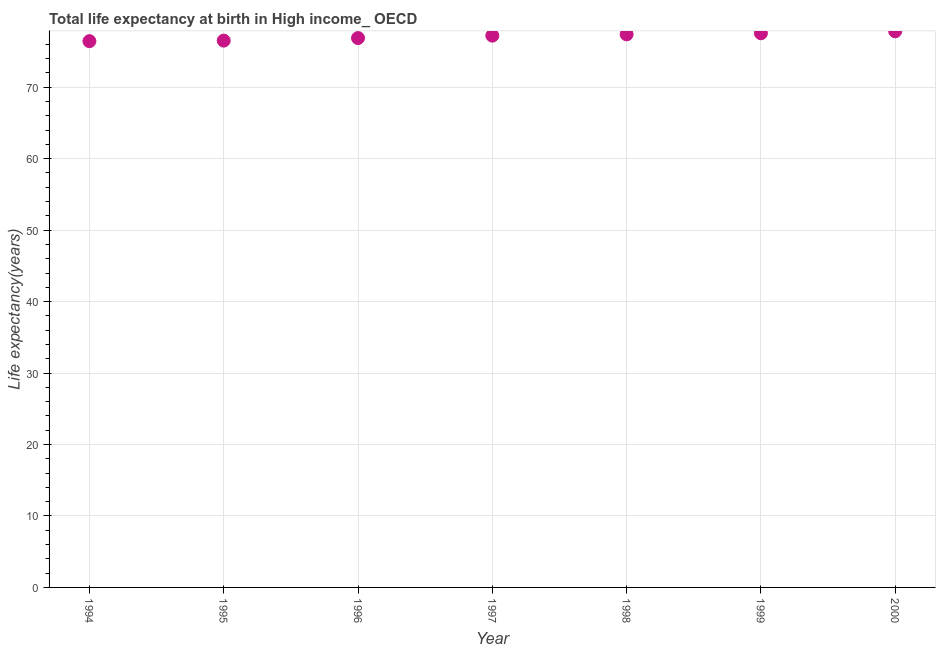What is the life expectancy at birth in 1997?
Provide a short and direct response. 77.22. Across all years, what is the maximum life expectancy at birth?
Make the answer very short. 77.83. Across all years, what is the minimum life expectancy at birth?
Keep it short and to the point. 76.45. In which year was the life expectancy at birth minimum?
Keep it short and to the point. 1994. What is the sum of the life expectancy at birth?
Offer a very short reply. 539.85. What is the difference between the life expectancy at birth in 1996 and 1999?
Provide a short and direct response. -0.67. What is the average life expectancy at birth per year?
Give a very brief answer. 77.12. What is the median life expectancy at birth?
Your answer should be compact. 77.22. In how many years, is the life expectancy at birth greater than 6 years?
Make the answer very short. 7. What is the ratio of the life expectancy at birth in 1997 to that in 1999?
Provide a succinct answer. 1. Is the life expectancy at birth in 1997 less than that in 2000?
Give a very brief answer. Yes. Is the difference between the life expectancy at birth in 1996 and 1998 greater than the difference between any two years?
Your response must be concise. No. What is the difference between the highest and the second highest life expectancy at birth?
Ensure brevity in your answer.  0.27. What is the difference between the highest and the lowest life expectancy at birth?
Make the answer very short. 1.38. In how many years, is the life expectancy at birth greater than the average life expectancy at birth taken over all years?
Offer a very short reply. 4. How many dotlines are there?
Offer a very short reply. 1. How many years are there in the graph?
Offer a very short reply. 7. What is the difference between two consecutive major ticks on the Y-axis?
Your response must be concise. 10. Does the graph contain any zero values?
Ensure brevity in your answer.  No. What is the title of the graph?
Offer a very short reply. Total life expectancy at birth in High income_ OECD. What is the label or title of the Y-axis?
Keep it short and to the point. Life expectancy(years). What is the Life expectancy(years) in 1994?
Provide a short and direct response. 76.45. What is the Life expectancy(years) in 1995?
Provide a succinct answer. 76.52. What is the Life expectancy(years) in 1996?
Provide a succinct answer. 76.88. What is the Life expectancy(years) in 1997?
Provide a succinct answer. 77.22. What is the Life expectancy(years) in 1998?
Provide a short and direct response. 77.4. What is the Life expectancy(years) in 1999?
Give a very brief answer. 77.55. What is the Life expectancy(years) in 2000?
Ensure brevity in your answer.  77.83. What is the difference between the Life expectancy(years) in 1994 and 1995?
Your answer should be compact. -0.07. What is the difference between the Life expectancy(years) in 1994 and 1996?
Your response must be concise. -0.43. What is the difference between the Life expectancy(years) in 1994 and 1997?
Provide a succinct answer. -0.77. What is the difference between the Life expectancy(years) in 1994 and 1998?
Keep it short and to the point. -0.96. What is the difference between the Life expectancy(years) in 1994 and 1999?
Your answer should be very brief. -1.11. What is the difference between the Life expectancy(years) in 1994 and 2000?
Offer a very short reply. -1.38. What is the difference between the Life expectancy(years) in 1995 and 1996?
Provide a succinct answer. -0.36. What is the difference between the Life expectancy(years) in 1995 and 1997?
Provide a succinct answer. -0.7. What is the difference between the Life expectancy(years) in 1995 and 1998?
Make the answer very short. -0.88. What is the difference between the Life expectancy(years) in 1995 and 1999?
Provide a succinct answer. -1.03. What is the difference between the Life expectancy(years) in 1995 and 2000?
Your answer should be very brief. -1.3. What is the difference between the Life expectancy(years) in 1996 and 1997?
Offer a very short reply. -0.34. What is the difference between the Life expectancy(years) in 1996 and 1998?
Provide a succinct answer. -0.52. What is the difference between the Life expectancy(years) in 1996 and 1999?
Offer a terse response. -0.67. What is the difference between the Life expectancy(years) in 1996 and 2000?
Your answer should be compact. -0.94. What is the difference between the Life expectancy(years) in 1997 and 1998?
Your answer should be very brief. -0.18. What is the difference between the Life expectancy(years) in 1997 and 1999?
Provide a short and direct response. -0.33. What is the difference between the Life expectancy(years) in 1997 and 2000?
Provide a succinct answer. -0.61. What is the difference between the Life expectancy(years) in 1998 and 1999?
Ensure brevity in your answer.  -0.15. What is the difference between the Life expectancy(years) in 1998 and 2000?
Provide a short and direct response. -0.42. What is the difference between the Life expectancy(years) in 1999 and 2000?
Provide a short and direct response. -0.27. What is the ratio of the Life expectancy(years) in 1994 to that in 1996?
Give a very brief answer. 0.99. What is the ratio of the Life expectancy(years) in 1994 to that in 1998?
Provide a succinct answer. 0.99. What is the ratio of the Life expectancy(years) in 1995 to that in 1996?
Give a very brief answer. 0.99. What is the ratio of the Life expectancy(years) in 1995 to that in 1998?
Provide a succinct answer. 0.99. What is the ratio of the Life expectancy(years) in 1995 to that in 1999?
Your answer should be compact. 0.99. What is the ratio of the Life expectancy(years) in 1996 to that in 1998?
Provide a succinct answer. 0.99. What is the ratio of the Life expectancy(years) in 1996 to that in 1999?
Your answer should be very brief. 0.99. What is the ratio of the Life expectancy(years) in 1996 to that in 2000?
Provide a short and direct response. 0.99. What is the ratio of the Life expectancy(years) in 1997 to that in 1998?
Keep it short and to the point. 1. What is the ratio of the Life expectancy(years) in 1997 to that in 2000?
Make the answer very short. 0.99. What is the ratio of the Life expectancy(years) in 1998 to that in 1999?
Offer a terse response. 1. What is the ratio of the Life expectancy(years) in 1998 to that in 2000?
Provide a short and direct response. 0.99. 